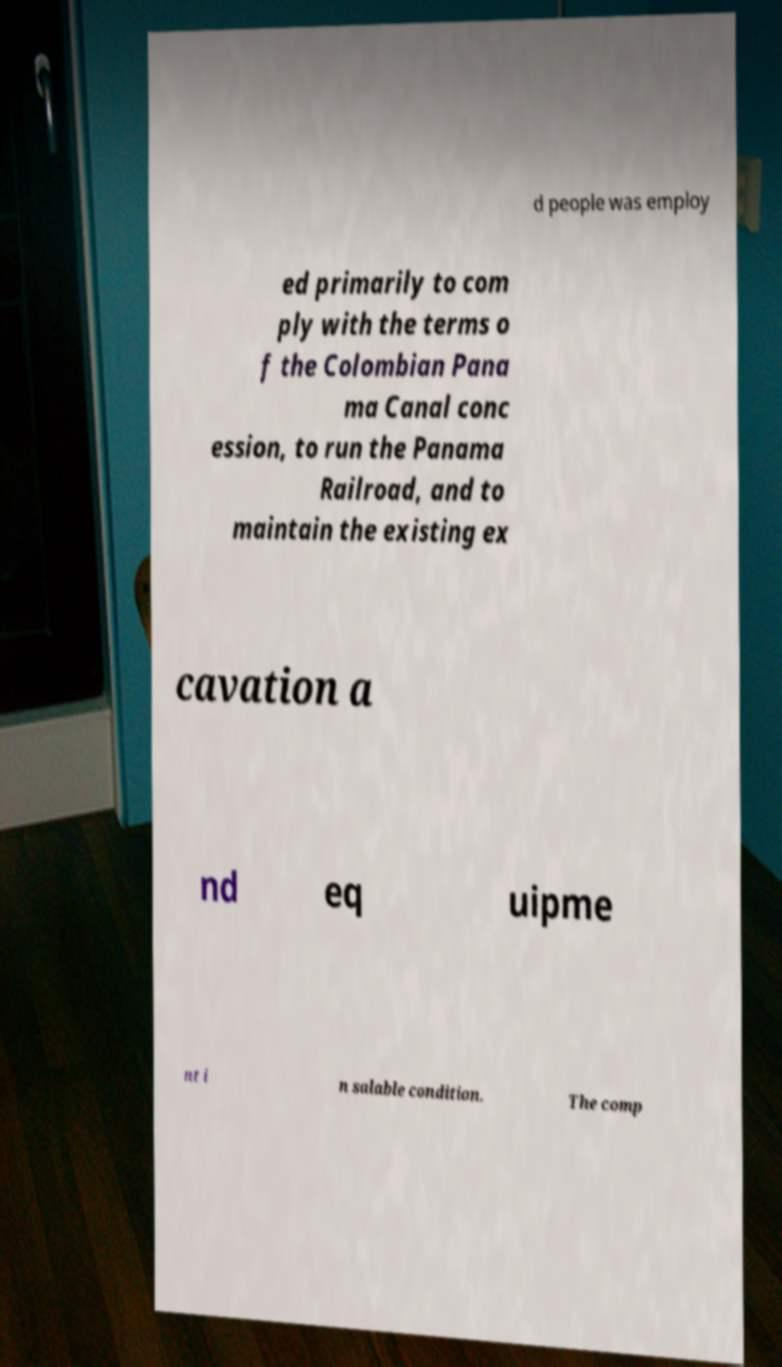Could you assist in decoding the text presented in this image and type it out clearly? d people was employ ed primarily to com ply with the terms o f the Colombian Pana ma Canal conc ession, to run the Panama Railroad, and to maintain the existing ex cavation a nd eq uipme nt i n salable condition. The comp 